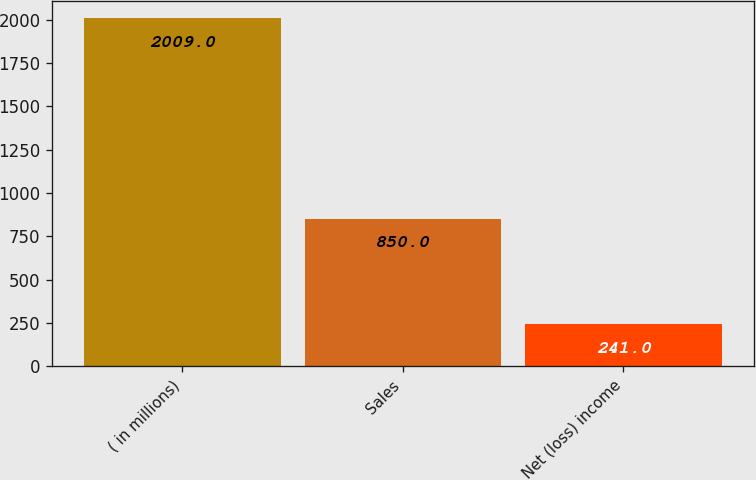<chart> <loc_0><loc_0><loc_500><loc_500><bar_chart><fcel>( in millions)<fcel>Sales<fcel>Net (loss) income<nl><fcel>2009<fcel>850<fcel>241<nl></chart> 